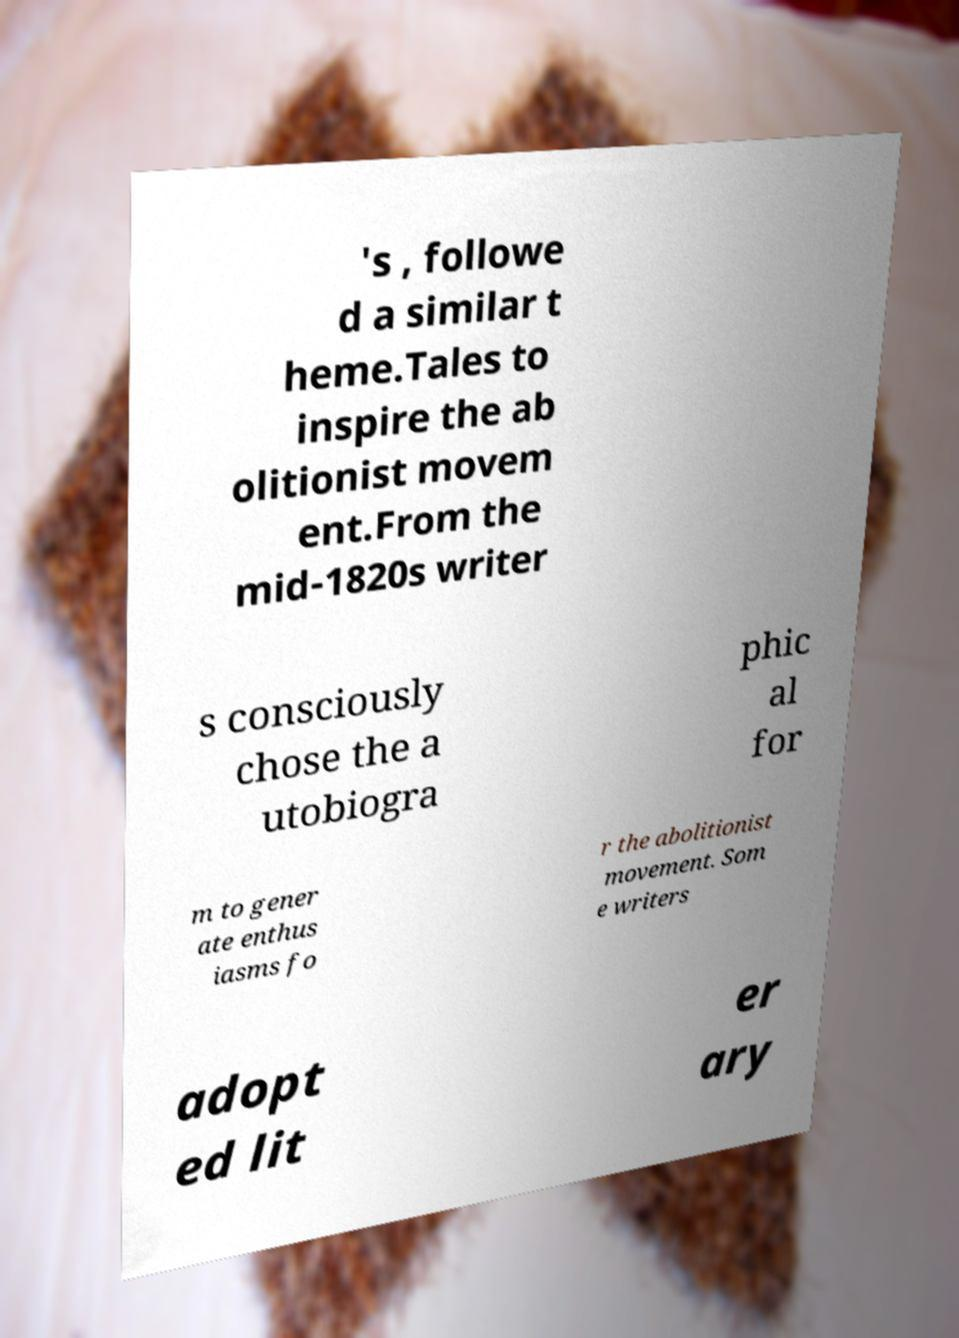For documentation purposes, I need the text within this image transcribed. Could you provide that? 's , followe d a similar t heme.Tales to inspire the ab olitionist movem ent.From the mid-1820s writer s consciously chose the a utobiogra phic al for m to gener ate enthus iasms fo r the abolitionist movement. Som e writers adopt ed lit er ary 